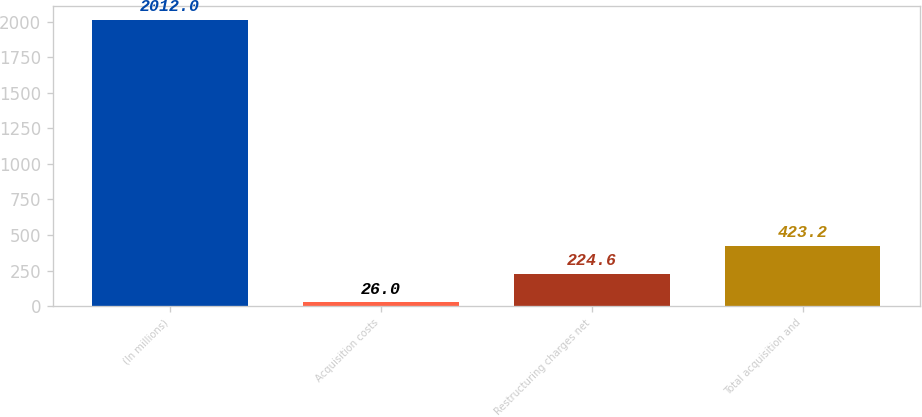Convert chart to OTSL. <chart><loc_0><loc_0><loc_500><loc_500><bar_chart><fcel>(In millions)<fcel>Acquisition costs<fcel>Restructuring charges net<fcel>Total acquisition and<nl><fcel>2012<fcel>26<fcel>224.6<fcel>423.2<nl></chart> 